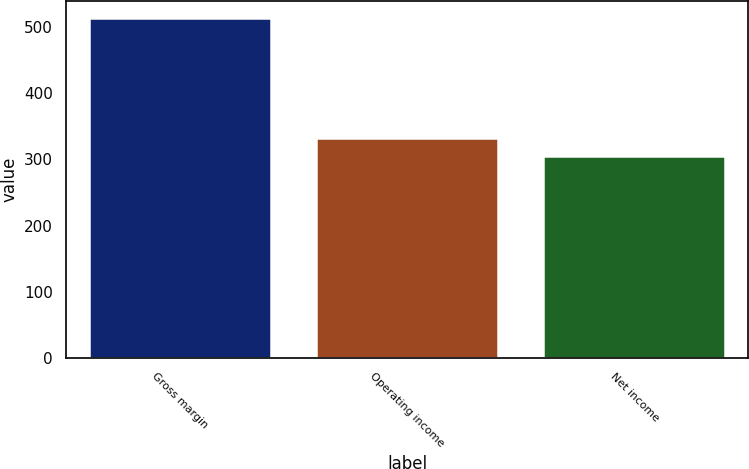Convert chart to OTSL. <chart><loc_0><loc_0><loc_500><loc_500><bar_chart><fcel>Gross margin<fcel>Operating income<fcel>Net income<nl><fcel>513<fcel>332<fcel>305<nl></chart> 